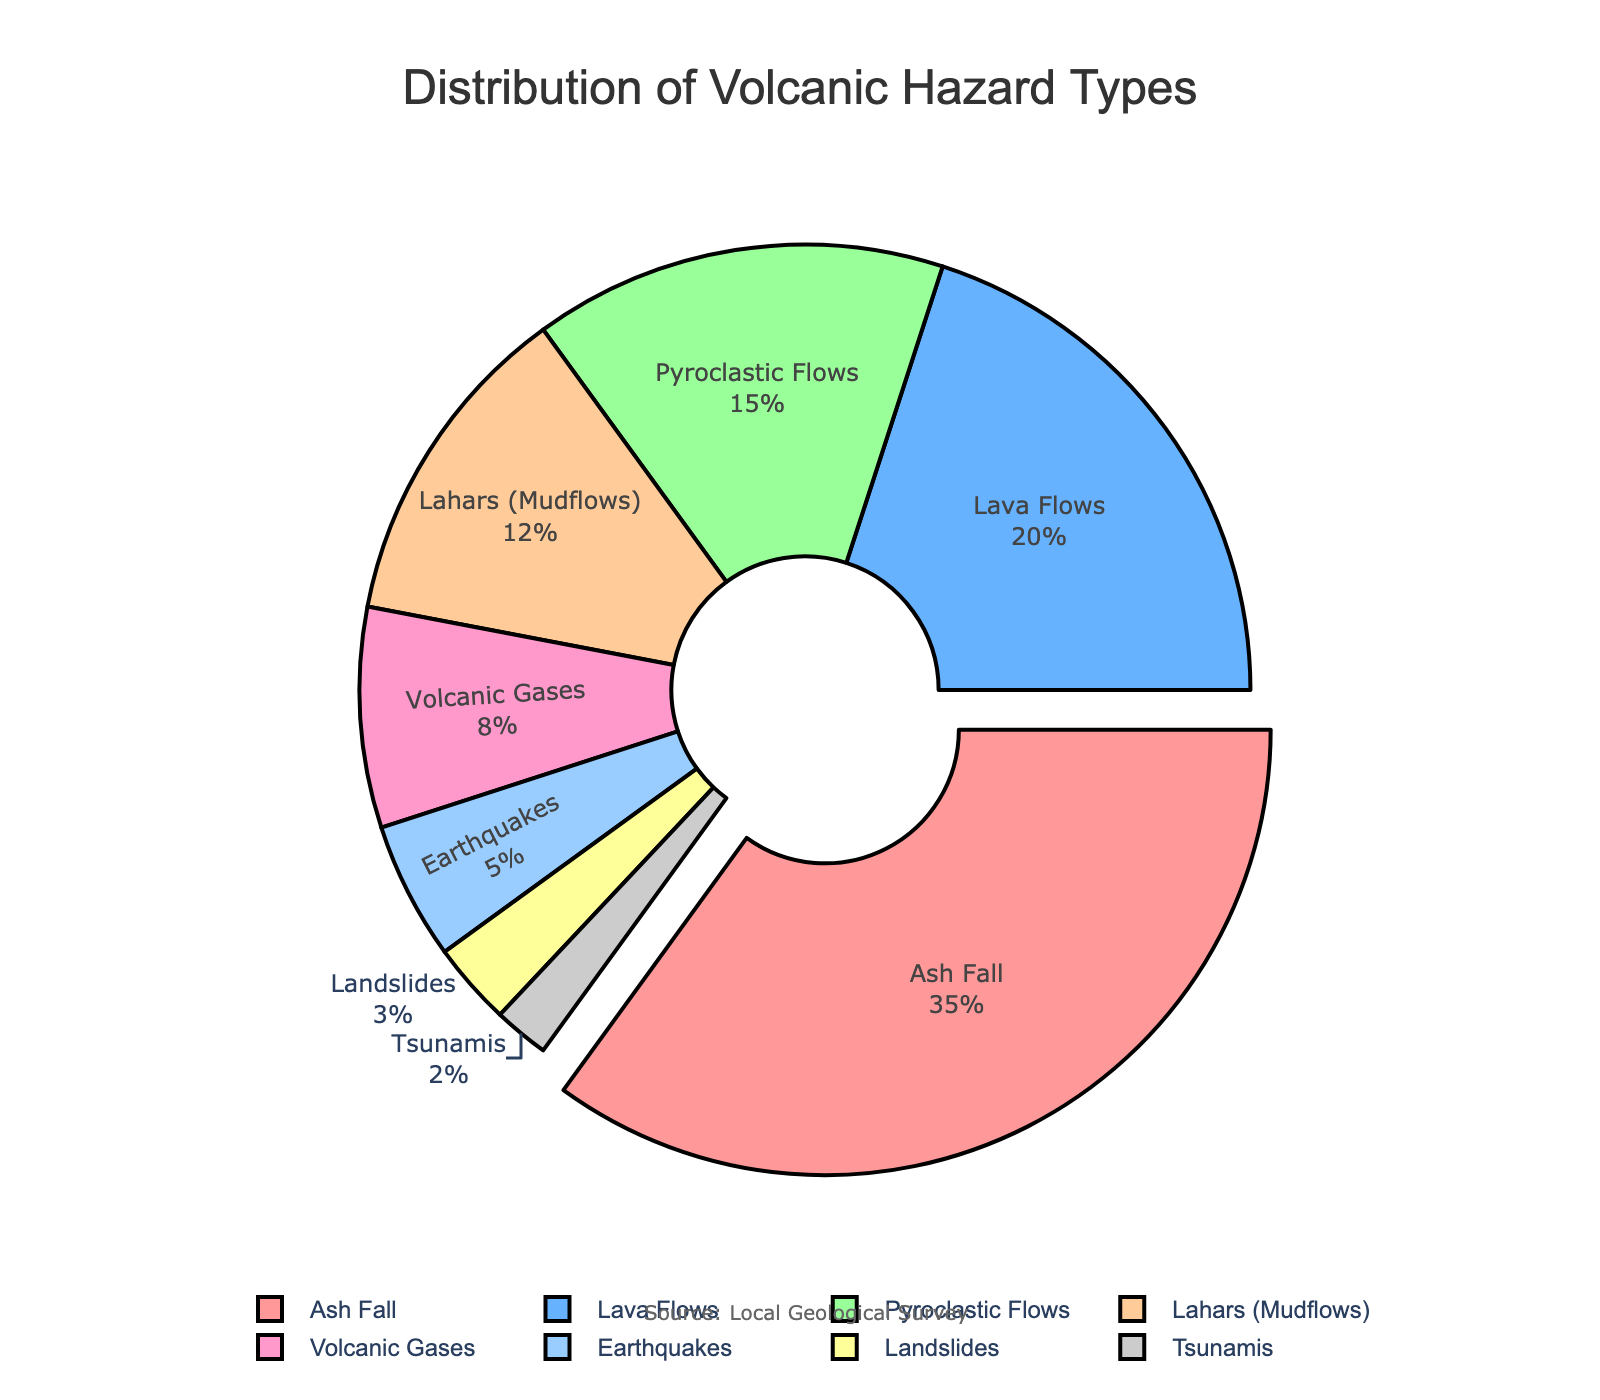Which volcanic hazard type has the highest percentage? The pie chart reveals that "Ash Fall" has the largest segment, with 35% of the distribution.
Answer: Ash Fall What is the combined percentage of Lava Flows and Pyroclastic Flows? The pie chart shows that Lava Flows account for 20% and Pyroclastic Flows account for 15%. Adding these together gives 20% + 15% = 35%.
Answer: 35% Which hazard type is ranked third in terms of distribution percentage? The pie chart lists the percentages, and the third largest segment is "Pyroclastic Flows" at 15%.
Answer: Pyroclastic Flows How much smaller is the percentage of Lahars compared to Ash Fall? Ash Fall is 35% and Lahars are 12%. The difference is 35% - 12% = 23%.
Answer: 23% If you add the percentages of Volcanic Gases, Earthquakes, Landslides, and Tsunamis, what is the total? According to the chart, Volcanic Gases are 8%, Earthquakes are 5%, Landslides are 3%, and Tsunamis are 2%. Adding these together gives 8% + 5% + 3% + 2% = 18%.
Answer: 18% Which hazard type has the smallest percentage, and what is that percentage? The smallest segment on the pie chart is for "Tsunamis," which accounts for 2% of the distribution.
Answer: Tsunamis, 2% How does the percentage of Lava Flows compare to the sum of the percentages of Volcanic Gases and Earthquakes? Lava Flows are 20%. Volcanic Gases are 8% and Earthquakes are 5%. Their sum is 8% + 5% = 13%. Thus, Lava Flows (20%) are greater than the sum of Volcanic Gases and Earthquakes (13%).
Answer: Greater What percentage of the total does the highlighted hazard type represent, and why is it highlighted? The pie chart highlights the hazard type with the largest percentage, which is "Ash Fall" at 35%. It is highlighted because it represents the highest percentage among all hazard types.
Answer: 35%, Ash Fall is the highest percentage 